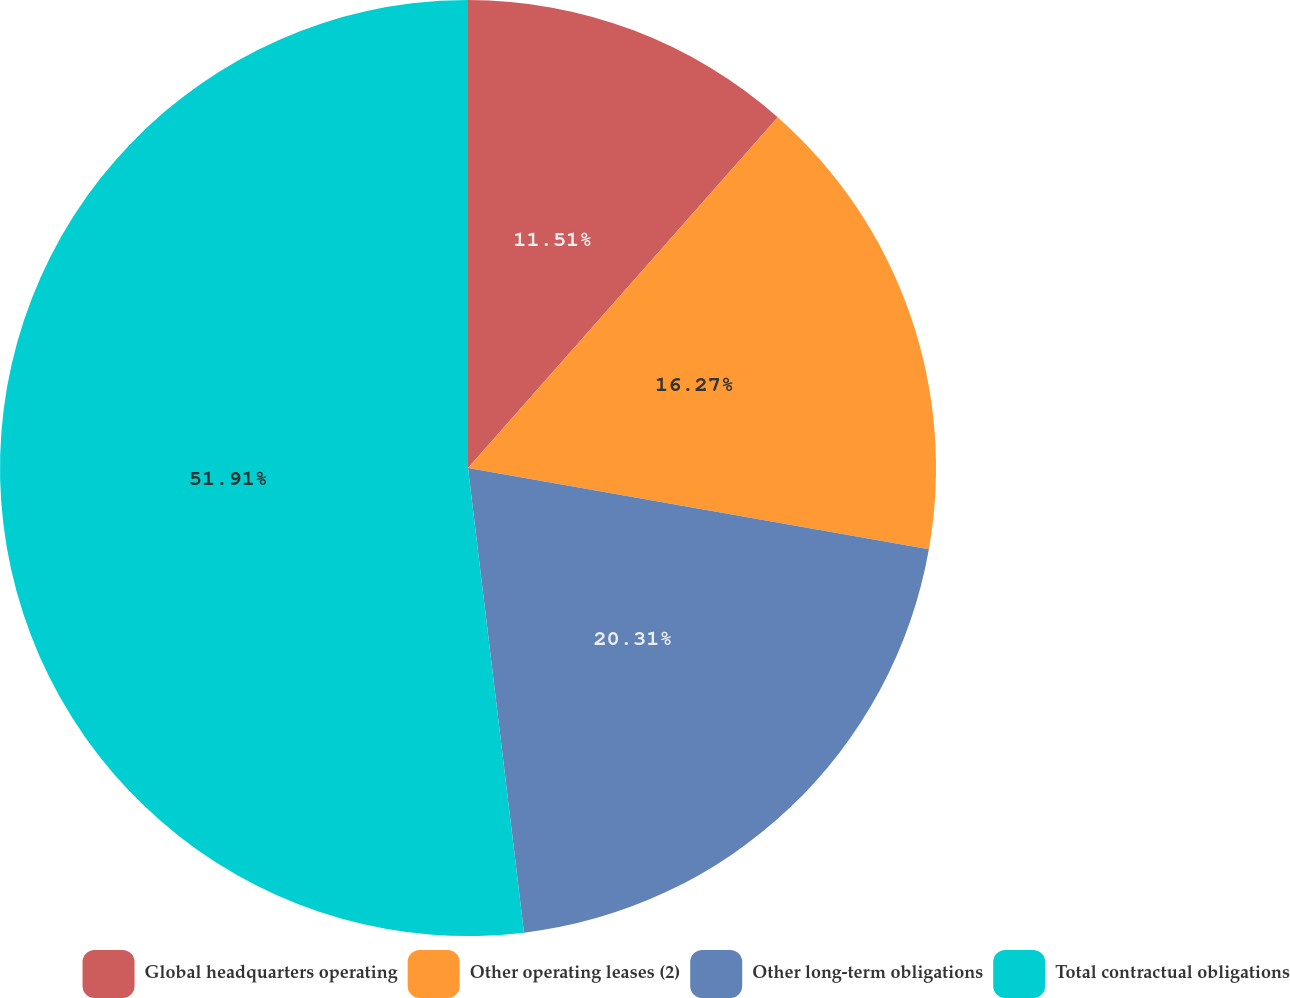<chart> <loc_0><loc_0><loc_500><loc_500><pie_chart><fcel>Global headquarters operating<fcel>Other operating leases (2)<fcel>Other long-term obligations<fcel>Total contractual obligations<nl><fcel>11.51%<fcel>16.27%<fcel>20.31%<fcel>51.91%<nl></chart> 